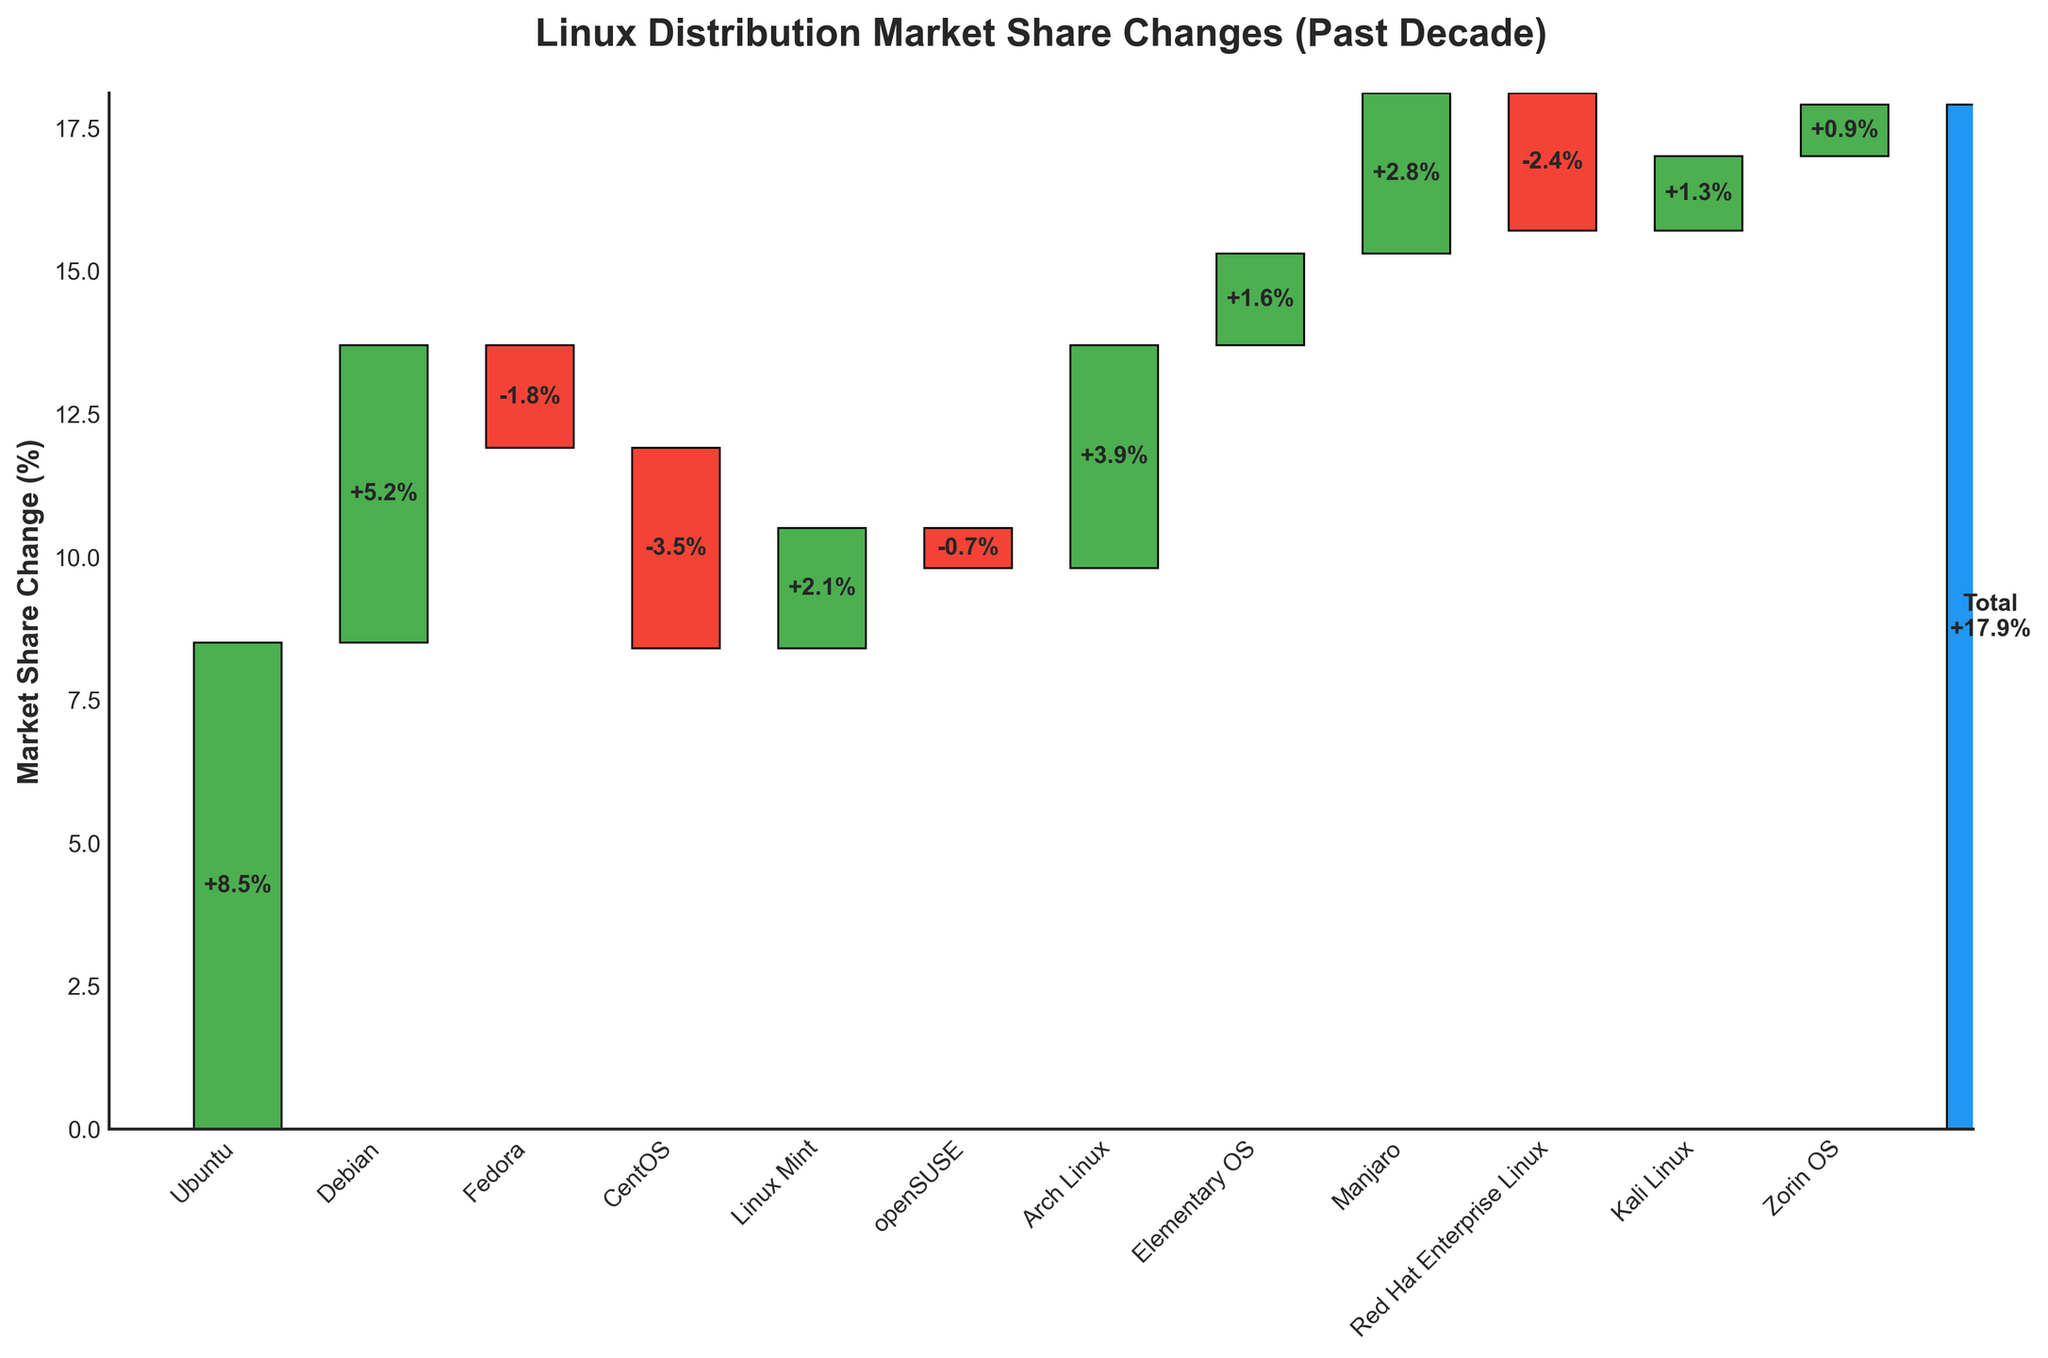How many distributions experienced a gain in market share? There are 7 distributions (Ubuntu, Debian, Linux Mint, Arch Linux, Elementary OS, Manjaro, and Kali Linux) that show a positive change in market share.
Answer: 7 What's the total market share change for distributions with a negative change? Combine the negative changes: Fedora (-1.8), CentOS (-3.5), openSUSE (-0.7), and Red Hat Enterprise Linux (-2.4). The sum is -1.8 - 3.5 - 0.7 - 2.4 = -8.4%.
Answer: -8.4% Which distribution had the largest positive change? The distribution with the highest gain in market share is identified by the tallest green bar. Ubuntu, with a change of +8.5%, had the largest positive change.
Answer: Ubuntu Compare the market share changes of Fedora and CentOS. Which one lost more market share and by how much? Fedora lost -1.8% and CentOS lost -3.5%. To find the difference: -3.5 - (-1.8) = -3.5 + 1.8 = -1.7%. Hence, CentOS lost 1.7% more market share than Fedora.
Answer: CentOS by 1.7% What is the cumulative market share change right before Manjaro? Look at the cumulative impact up to Elementary OS. Summing up the changes for distributions before Manjaro: 8.5 + 5.2 - 1.8 - 3.5 + 2.1 - 0.7 + 3.9 + 1.6 = 15.3%.
Answer: 15.3% Does any distribution have a market share change between -1% and 1%? Zorin OS's market share change is +0.9%, and it is the only distribution within the range of -1% to 1%.
Answer: Yes, Zorin OS What is the average market share change for all distributions listed? Transform the changes to absolute values first and count the number of distributions. Sum of absolute values: 8.5 + 5.2 + 1.8 + 3.5 + 2.1 + 0.7 + 3.9 + 1.6 + 2.8 + 2.4 + 1.3 + 0.9 = 34.7. The average change: 34.7/12 = 2.89%.
Answer: 2.89% Which has a greater impact on the overall market share change, positive gains or negative losses? Sum up the positive and negative changes separately. Positive: 8.5 + 5.2 + 2.1 + 3.9 + 1.6 + 2.8 + 1.3 + 0.9 = 26.3%. Negative: -1.8 - 3.5 - 0.7 - 2.4 = -8.4%. Positive is greater because 26.3 > 8.4.
Answer: Positive gains Based on the visual, which distributions did not have any significant change (±2% market share)? Significant change is defined as a change greater than ±2%. OpenSUSE (-0.7%) and Zorin OS (+0.9%) had changes less than ±2%.
Answer: openSUSE, Zorin OS 